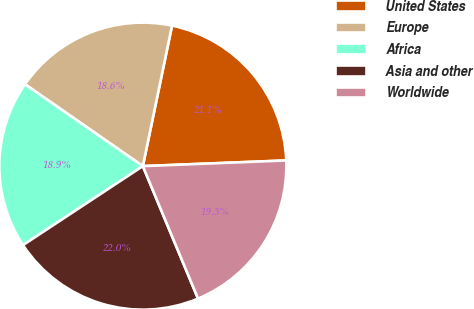Convert chart. <chart><loc_0><loc_0><loc_500><loc_500><pie_chart><fcel>United States<fcel>Europe<fcel>Africa<fcel>Asia and other<fcel>Worldwide<nl><fcel>21.11%<fcel>18.6%<fcel>18.94%<fcel>22.01%<fcel>19.35%<nl></chart> 